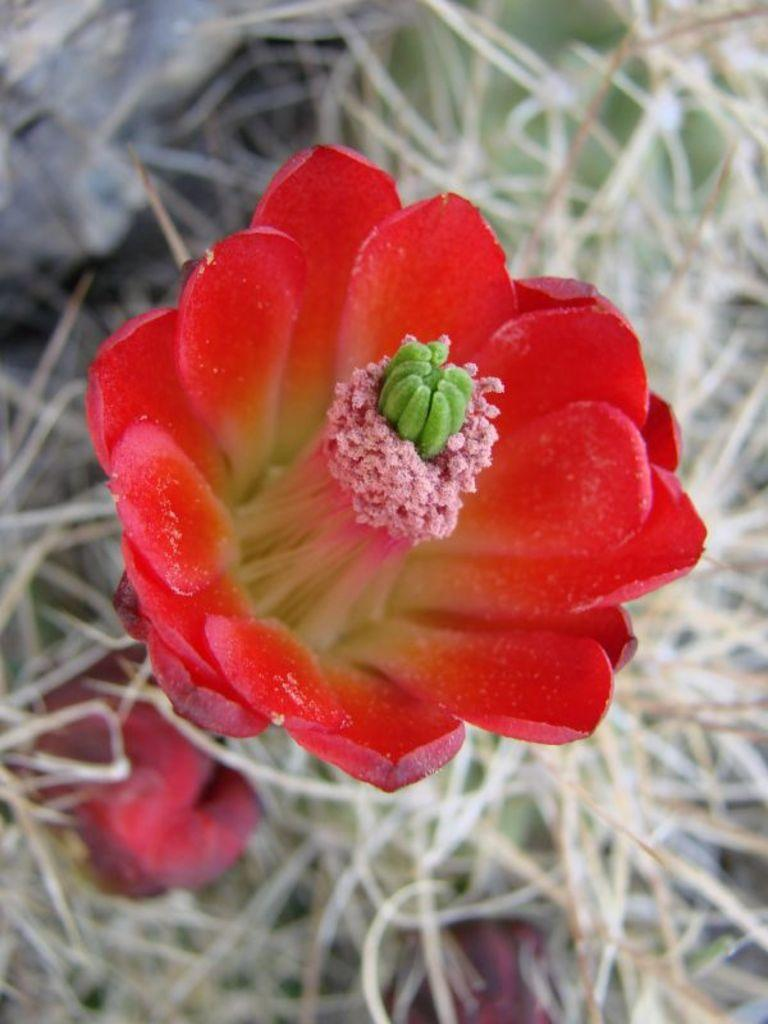What type of flower is in the image? There is a red flower in the image. What is the condition of the grass surrounding the flower? The grass around the flower is dry. How many dimes can be seen in the image? There are no dimes present in the image. What is the temperature of the flower in the image? The temperature of the flower cannot be determined from the image alone. 